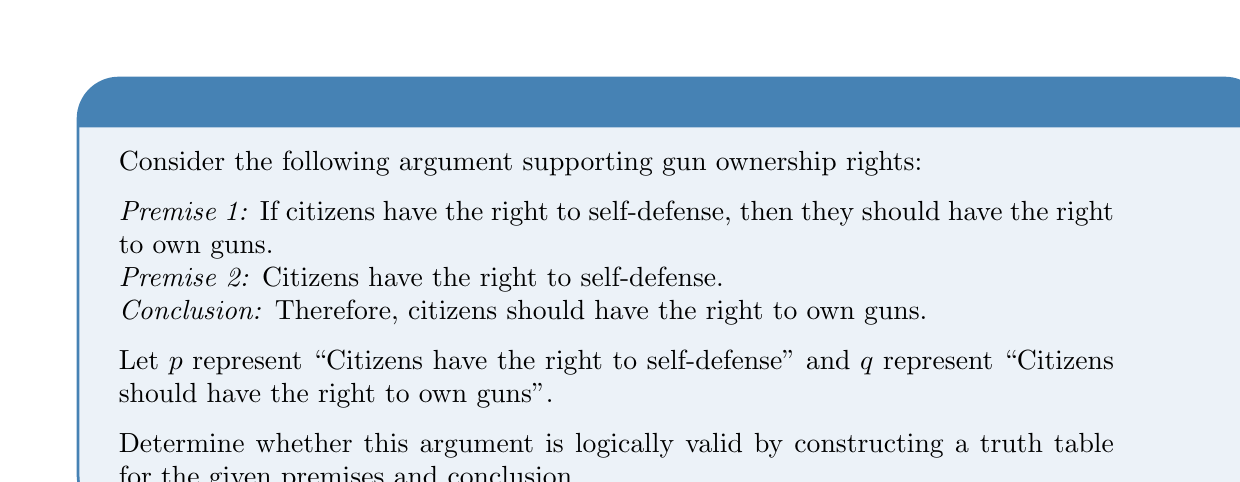What is the answer to this math problem? To determine the logical validity of this argument, we need to construct a truth table and analyze the relationship between the premises and the conclusion. An argument is considered logically valid if the conclusion is true whenever all premises are true.

Step 1: Identify the logical structure of the argument.
Premise 1: $p \rightarrow q$
Premise 2: $p$
Conclusion: $q$

Step 2: Construct the truth table for the premises and conclusion.

$$
\begin{array}{|c|c|c|c|c|}
\hline
p & q & p \rightarrow q & p & q \\
\hline
T & T & T & T & T \\
T & F & F & T & F \\
F & T & T & F & T \\
F & F & T & F & F \\
\hline
\end{array}
$$

Step 3: Analyze the truth table.
- We need to find rows where both premises (columns 3 and 4) are true.
- In this case, only the first row satisfies this condition.
- In this row, we see that the conclusion (column 5) is also true.

Step 4: Evaluate the validity.
Since the conclusion is true in all cases where both premises are true (which is only the first row in this case), the argument is logically valid.

This logical structure is known as Modus Ponens, which is a valid form of argument in propositional logic.
Answer: Logically valid 